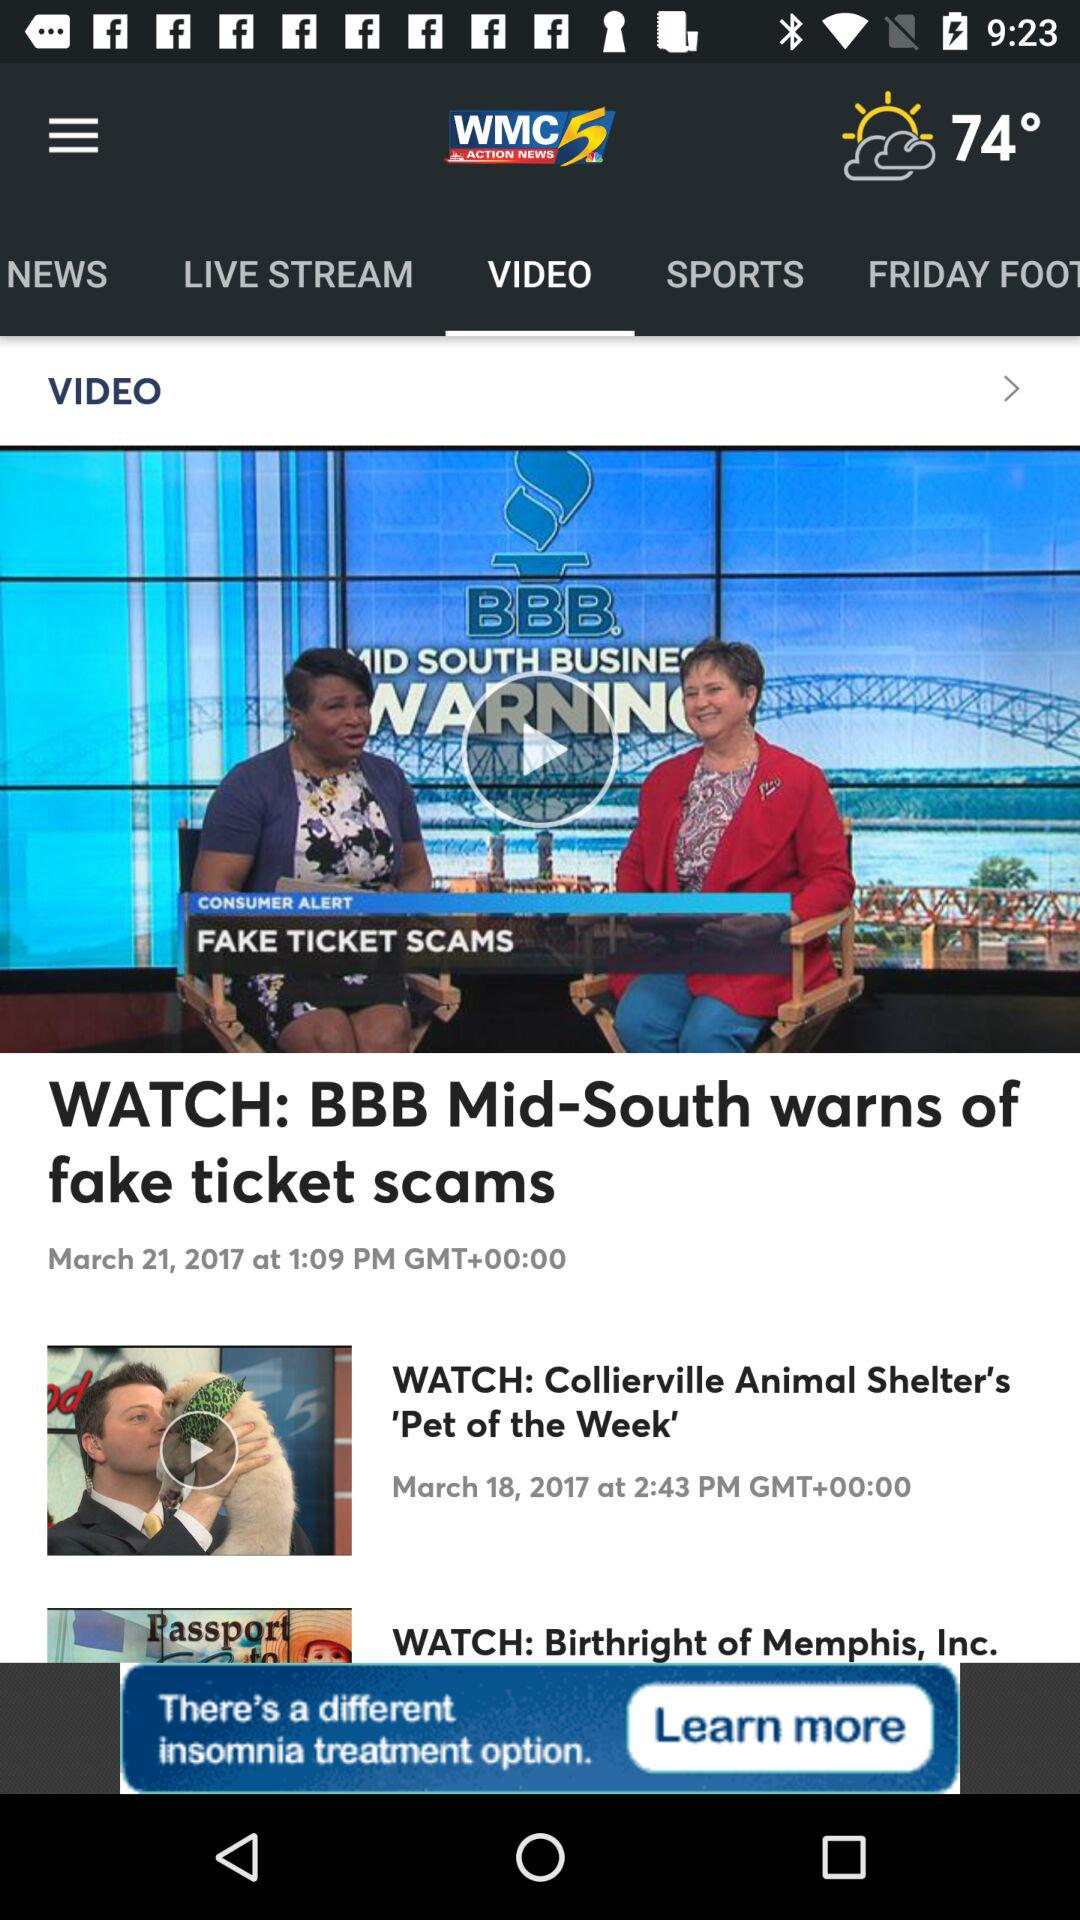Which tab is currently selected? The selected tab is "VIDEO". 